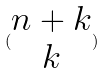Convert formula to latex. <formula><loc_0><loc_0><loc_500><loc_500>( \begin{matrix} n + k \\ k \end{matrix} )</formula> 